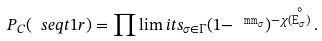<formula> <loc_0><loc_0><loc_500><loc_500>P _ { C } ( \ s e q t 1 r ) = \prod \lim i t s _ { \sigma \in \Gamma } ( 1 - \tt ^ { \, \ m m _ { \sigma } } ) ^ { - \chi ( \stackrel { \circ } { E _ { \sigma } } ) } \, .</formula> 